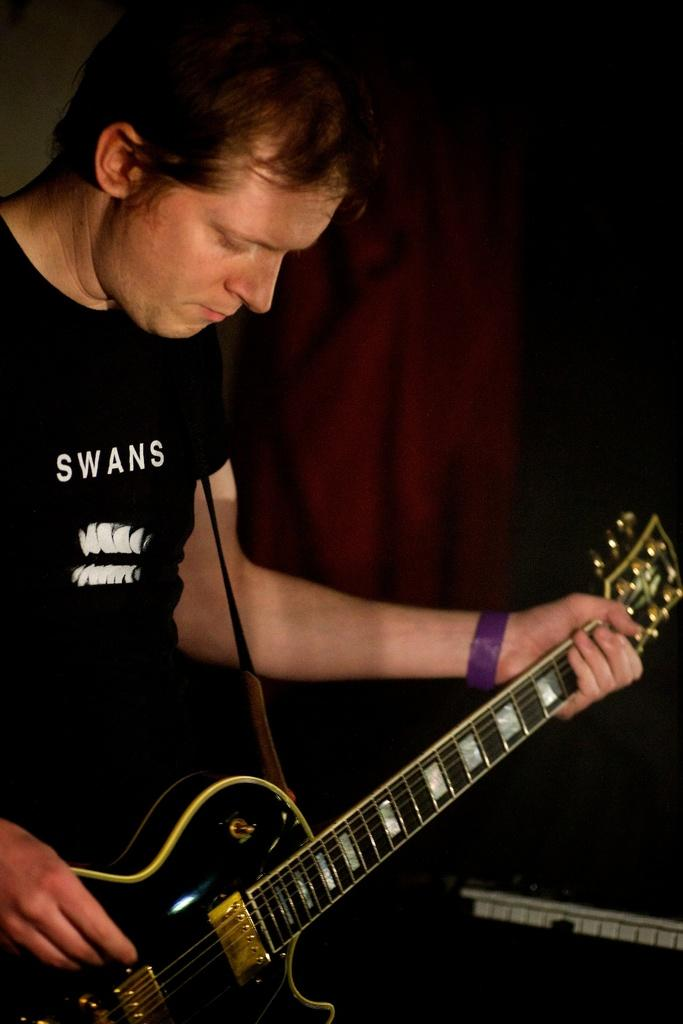What is the main subject of the image? The main subject of the image is a man. What is the man holding in the image? The man is holding a guitar. What type of silk fabric is the man wearing in the image? There is no mention of silk fabric or any clothing in the image; the man is simply holding a guitar. 